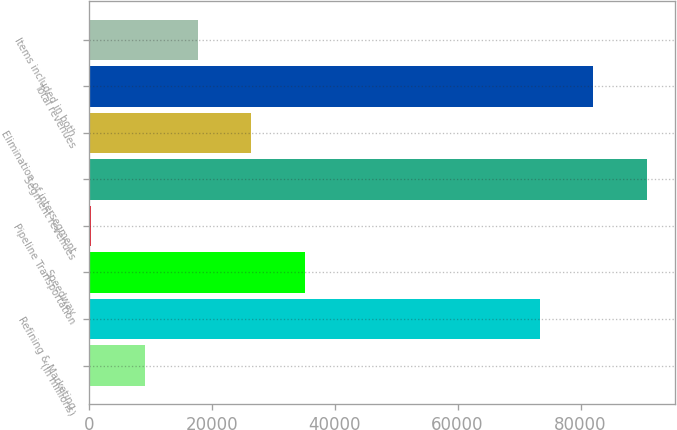Convert chart. <chart><loc_0><loc_0><loc_500><loc_500><bar_chart><fcel>(In millions)<fcel>Refining & Marketing<fcel>Speedway<fcel>Pipeline Transportation<fcel>Segment revenues<fcel>Elimination of intersegment<fcel>Total revenues<fcel>Items included in both<nl><fcel>9090.1<fcel>73381<fcel>35151.4<fcel>403<fcel>90755.2<fcel>26464.3<fcel>82068.1<fcel>17777.2<nl></chart> 